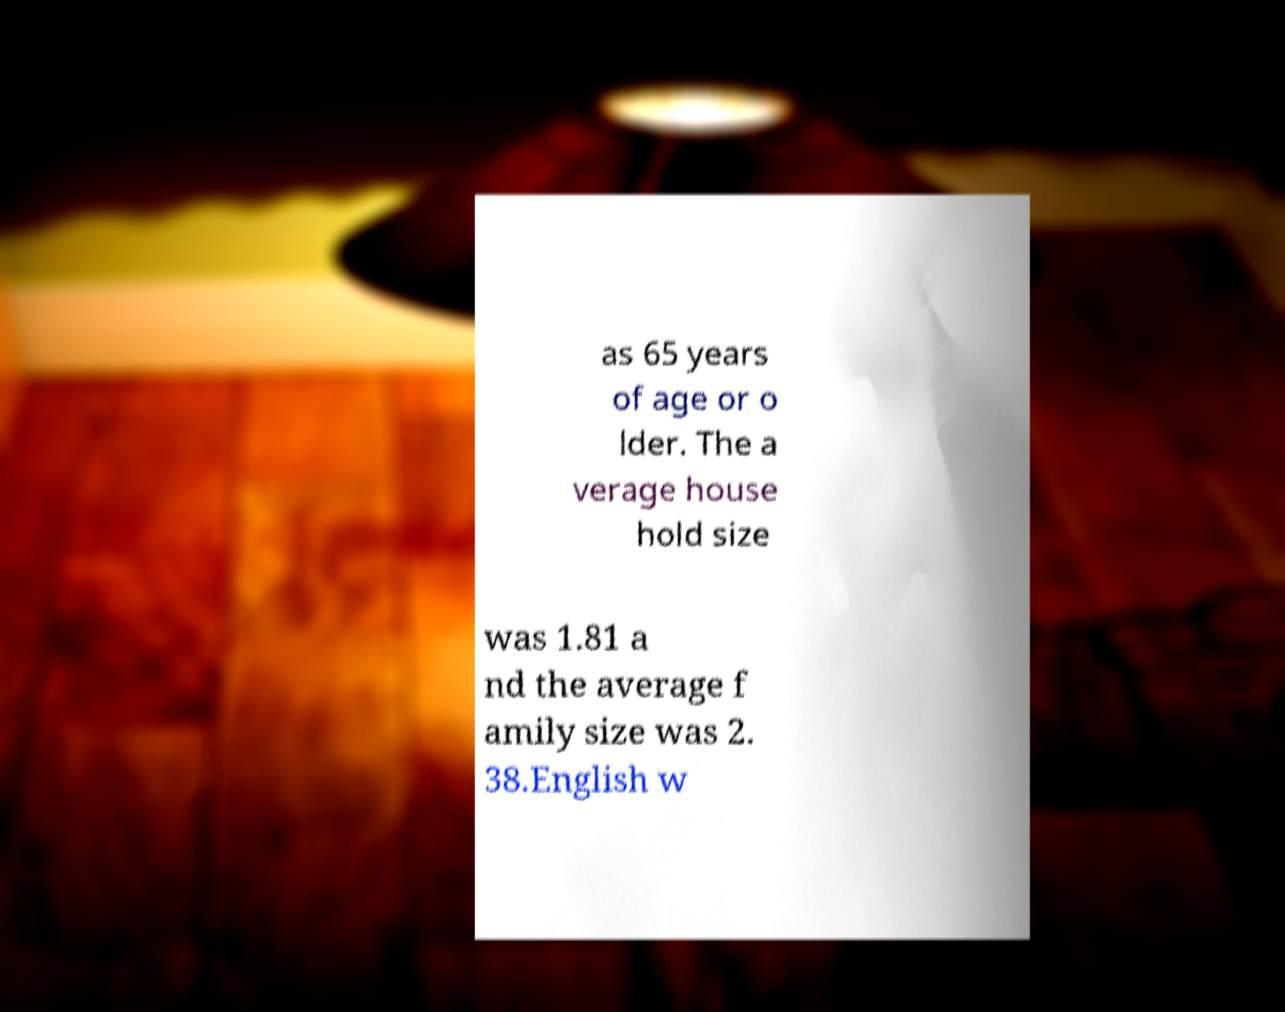Can you read and provide the text displayed in the image?This photo seems to have some interesting text. Can you extract and type it out for me? as 65 years of age or o lder. The a verage house hold size was 1.81 a nd the average f amily size was 2. 38.English w 